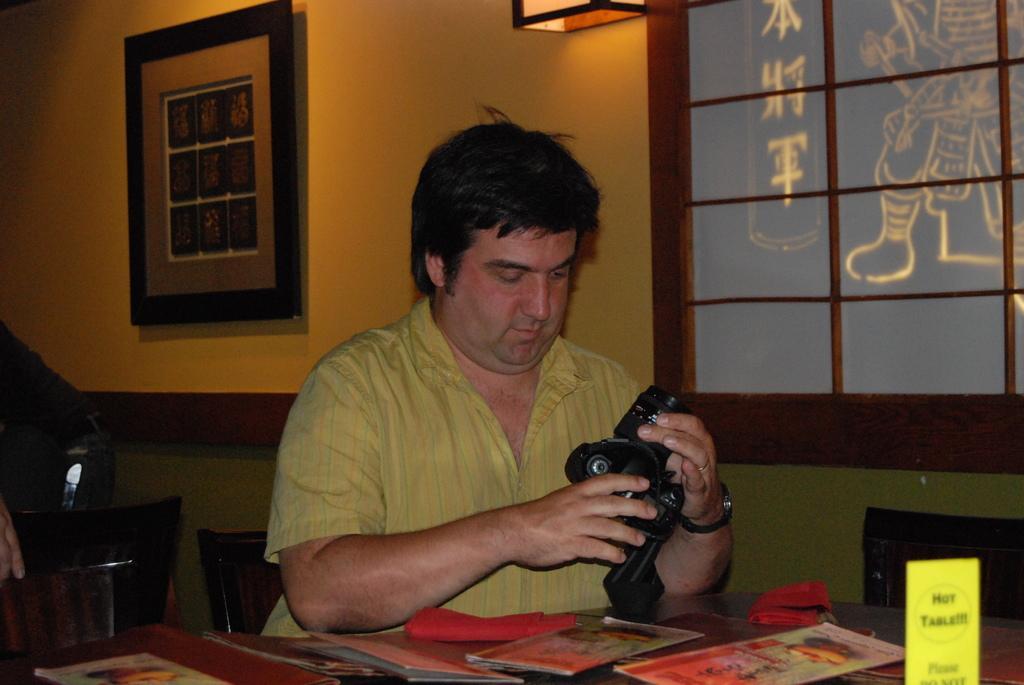In one or two sentences, can you explain what this image depicts? At the bottom of the image we can see a table, on the table we can see some books and banner. Behind the table a person is sitting and holding a camera. Behind him we can see a wall, on the wall we can see a glass window and frame. 